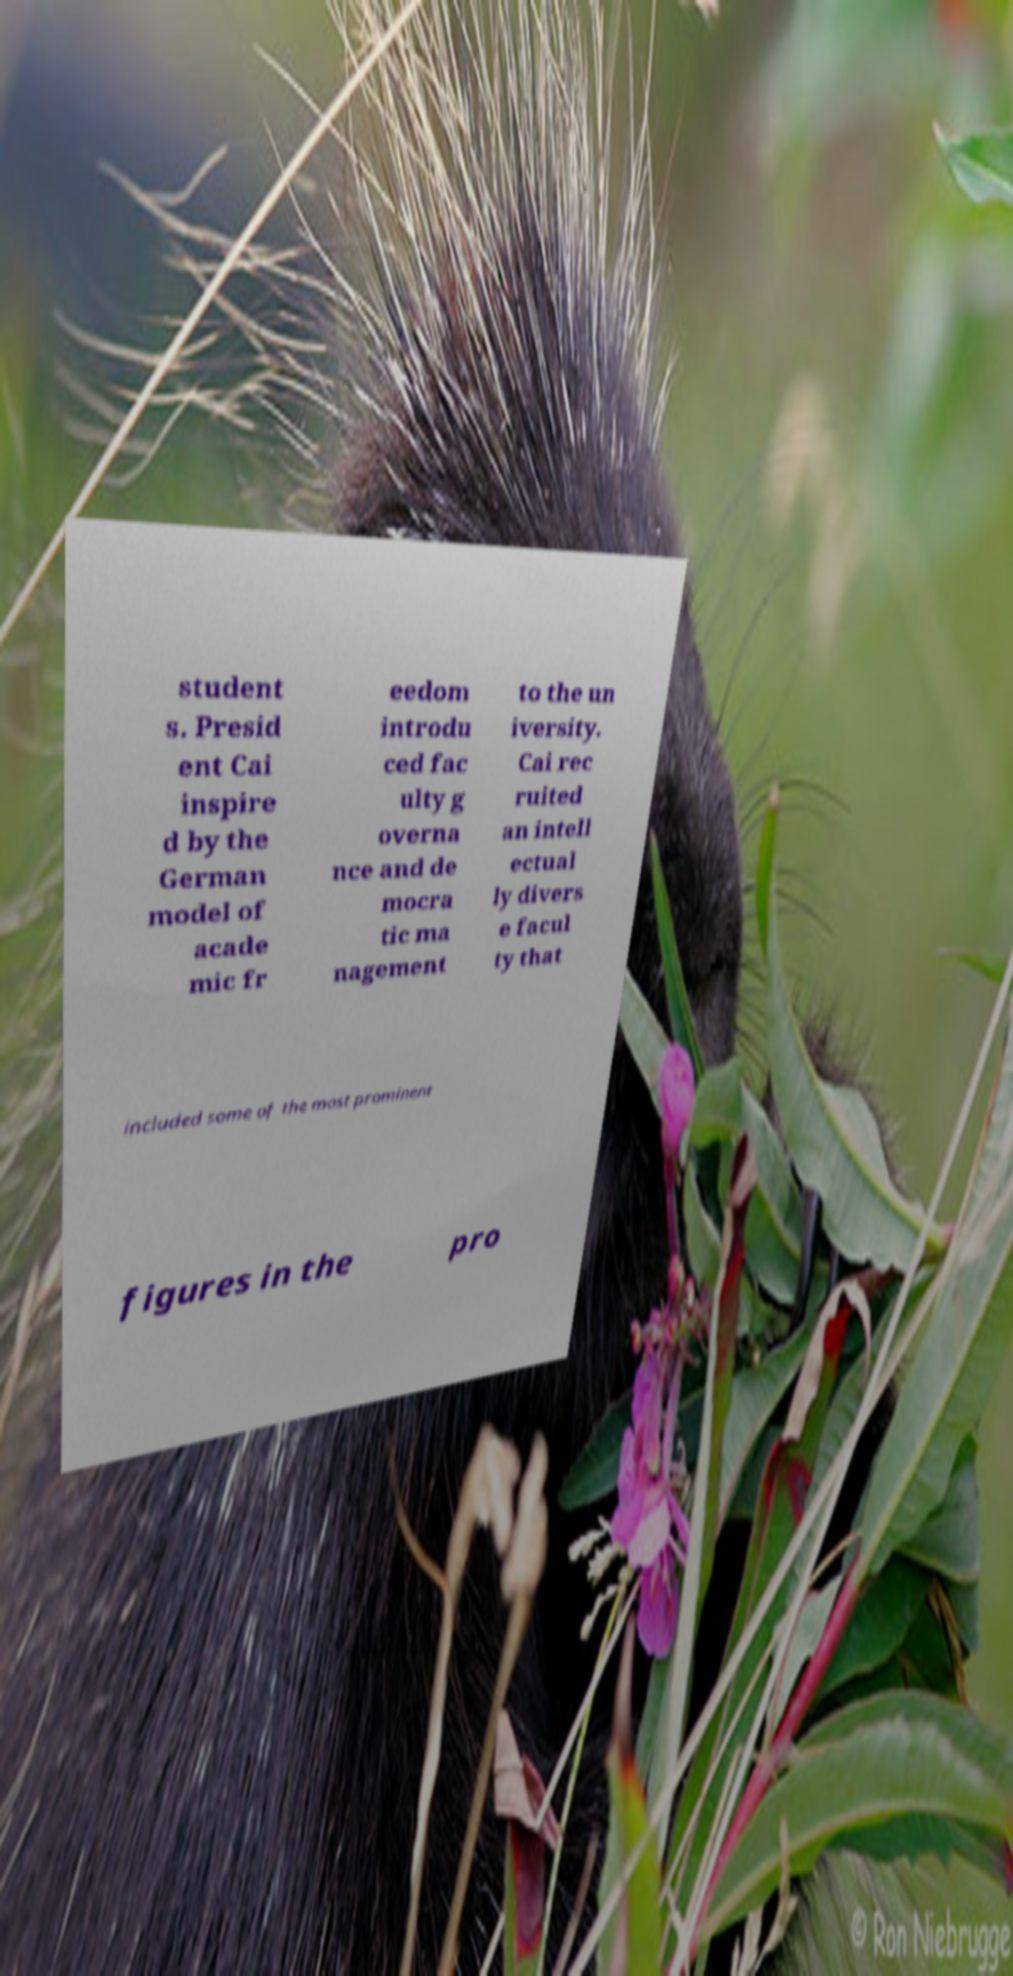Please identify and transcribe the text found in this image. student s. Presid ent Cai inspire d by the German model of acade mic fr eedom introdu ced fac ulty g overna nce and de mocra tic ma nagement to the un iversity. Cai rec ruited an intell ectual ly divers e facul ty that included some of the most prominent figures in the pro 